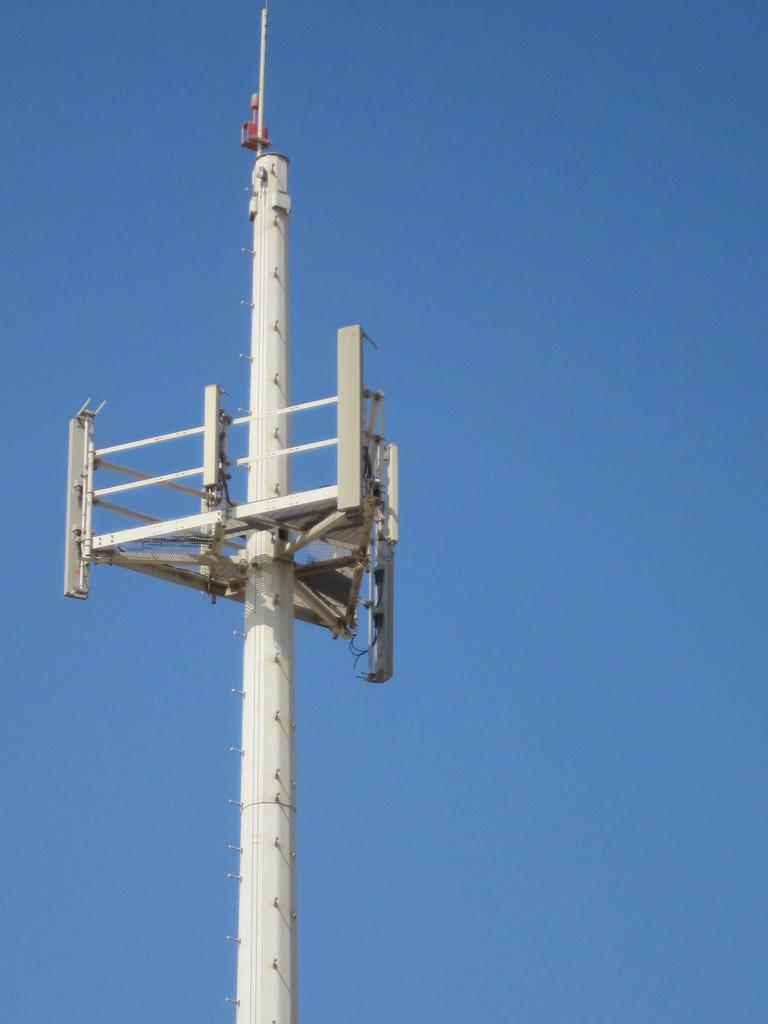What is the main structure in the picture? There is a tower in the picture. What color is the sky in the picture? The sky is blue in the picture. Can you see any flowers growing on the tower in the picture? There are no flowers visible on the tower in the picture. Are there any icicles hanging from the tower in the picture? There is no mention of icicles in the provided facts, and therefore we cannot determine if any are present in the image. 